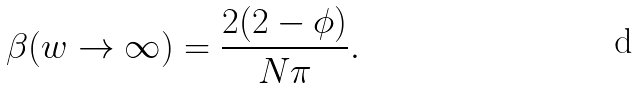<formula> <loc_0><loc_0><loc_500><loc_500>\beta ( w \rightarrow \infty ) = \frac { 2 ( 2 - \phi ) } { N \pi } .</formula> 